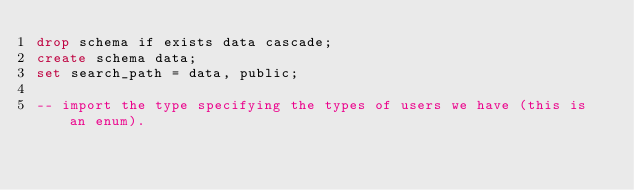Convert code to text. <code><loc_0><loc_0><loc_500><loc_500><_SQL_>drop schema if exists data cascade;
create schema data;
set search_path = data, public;

-- import the type specifying the types of users we have (this is an enum).</code> 